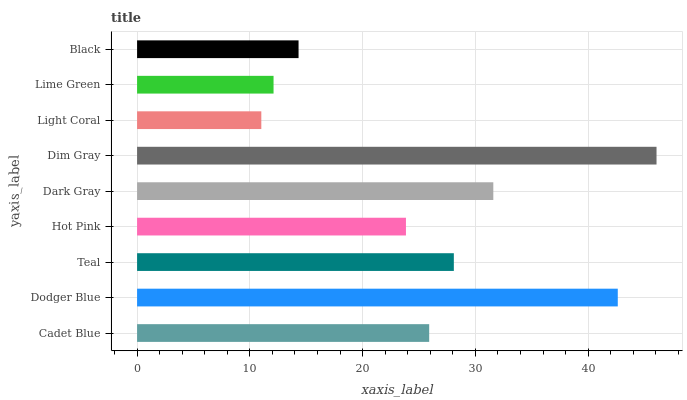Is Light Coral the minimum?
Answer yes or no. Yes. Is Dim Gray the maximum?
Answer yes or no. Yes. Is Dodger Blue the minimum?
Answer yes or no. No. Is Dodger Blue the maximum?
Answer yes or no. No. Is Dodger Blue greater than Cadet Blue?
Answer yes or no. Yes. Is Cadet Blue less than Dodger Blue?
Answer yes or no. Yes. Is Cadet Blue greater than Dodger Blue?
Answer yes or no. No. Is Dodger Blue less than Cadet Blue?
Answer yes or no. No. Is Cadet Blue the high median?
Answer yes or no. Yes. Is Cadet Blue the low median?
Answer yes or no. Yes. Is Dim Gray the high median?
Answer yes or no. No. Is Teal the low median?
Answer yes or no. No. 